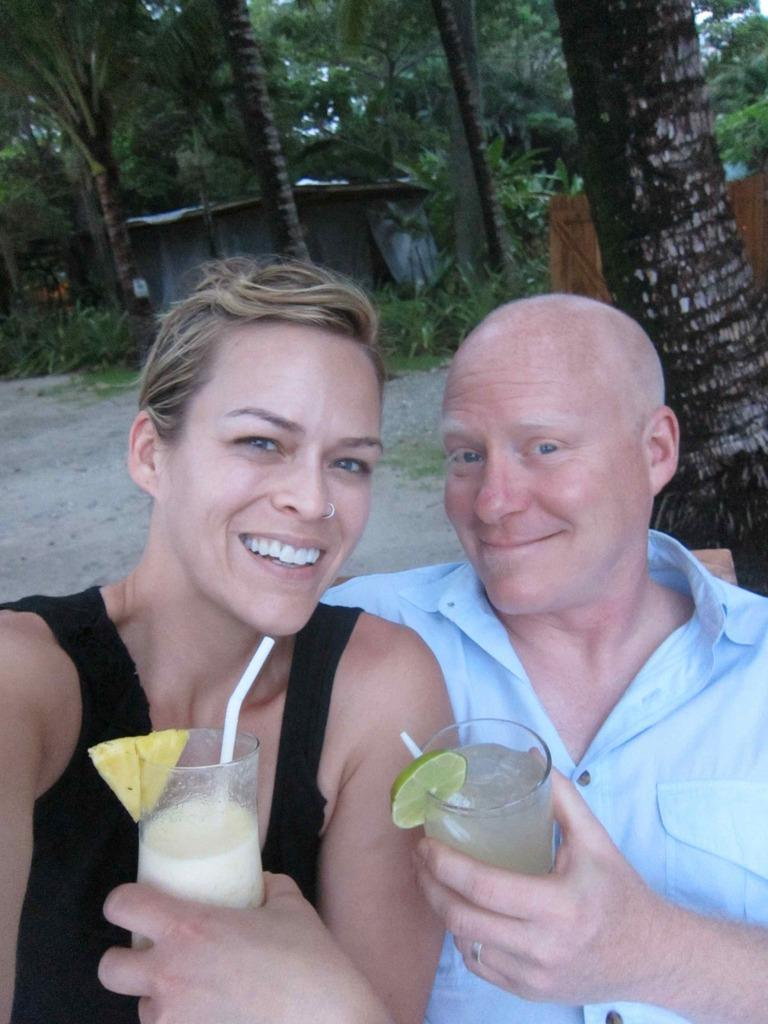How many people are sitting in the image? There are two persons sitting in the image. What are the persons holding in their hands? The persons are holding glasses. What can be seen in the background of the image? There is a house and trees visible in the background of the image. Can you tell me how many times the person on the left kicked the ball in the image? There is no ball present in the image, so it is not possible to determine how many times the person on the left kicked it. 